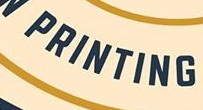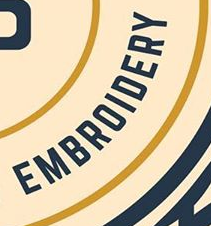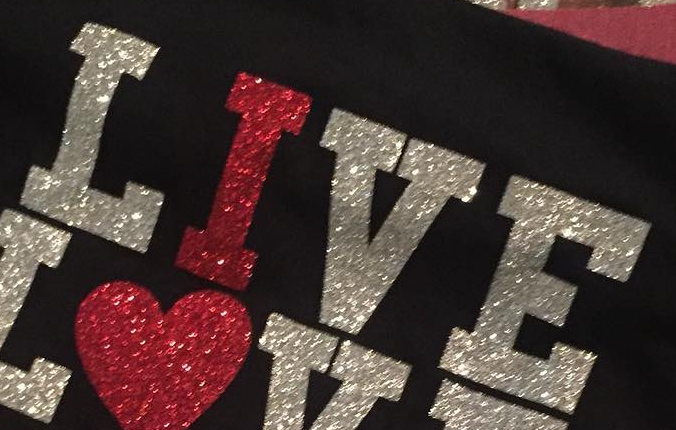Transcribe the words shown in these images in order, separated by a semicolon. PRINTING; EMBROIDERY; LIVE 